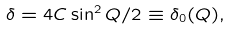<formula> <loc_0><loc_0><loc_500><loc_500>\delta = 4 C \sin ^ { 2 } Q / 2 \equiv \delta _ { 0 } ( Q ) ,</formula> 